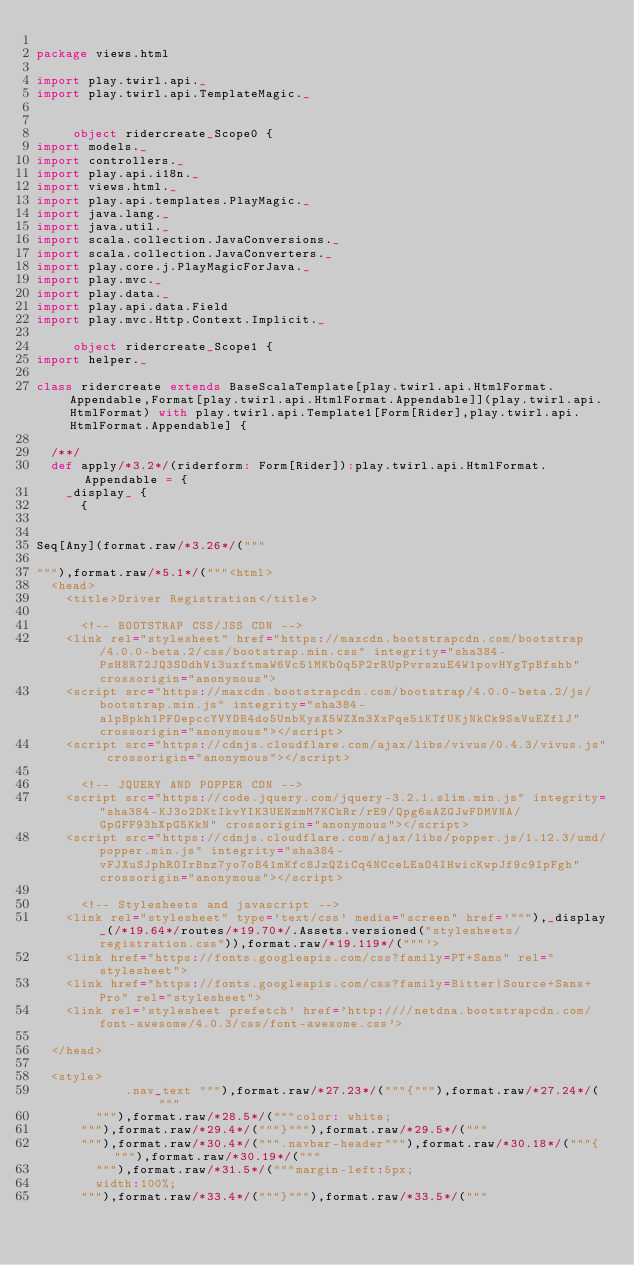Convert code to text. <code><loc_0><loc_0><loc_500><loc_500><_Scala_>
package views.html

import play.twirl.api._
import play.twirl.api.TemplateMagic._


     object ridercreate_Scope0 {
import models._
import controllers._
import play.api.i18n._
import views.html._
import play.api.templates.PlayMagic._
import java.lang._
import java.util._
import scala.collection.JavaConversions._
import scala.collection.JavaConverters._
import play.core.j.PlayMagicForJava._
import play.mvc._
import play.data._
import play.api.data.Field
import play.mvc.Http.Context.Implicit._

     object ridercreate_Scope1 {
import helper._

class ridercreate extends BaseScalaTemplate[play.twirl.api.HtmlFormat.Appendable,Format[play.twirl.api.HtmlFormat.Appendable]](play.twirl.api.HtmlFormat) with play.twirl.api.Template1[Form[Rider],play.twirl.api.HtmlFormat.Appendable] {

  /**/
  def apply/*3.2*/(riderform: Form[Rider]):play.twirl.api.HtmlFormat.Appendable = {
    _display_ {
      {


Seq[Any](format.raw/*3.26*/("""

"""),format.raw/*5.1*/("""<html>
	<head>
		<title>Driver Registration</title>

			<!-- BOOTSTRAP CSS/JSS CDN -->
		<link rel="stylesheet" href="https://maxcdn.bootstrapcdn.com/bootstrap/4.0.0-beta.2/css/bootstrap.min.css" integrity="sha384-PsH8R72JQ3SOdhVi3uxftmaW6Vc51MKb0q5P2rRUpPvrszuE4W1povHYgTpBfshb" crossorigin="anonymous">
		<script src="https://maxcdn.bootstrapcdn.com/bootstrap/4.0.0-beta.2/js/bootstrap.min.js" integrity="sha384-alpBpkh1PFOepccYVYDB4do5UnbKysX5WZXm3XxPqe5iKTfUKjNkCk9SaVuEZflJ" crossorigin="anonymous"></script>
		<script src="https://cdnjs.cloudflare.com/ajax/libs/vivus/0.4.3/vivus.js" crossorigin="anonymous"></script>

			<!-- JQUERY AND POPPER CDN -->
		<script src="https://code.jquery.com/jquery-3.2.1.slim.min.js" integrity="sha384-KJ3o2DKtIkvYIK3UENzmM7KCkRr/rE9/Qpg6aAZGJwFDMVNA/GpGFF93hXpG5KkN" crossorigin="anonymous"></script>
		<script src="https://cdnjs.cloudflare.com/ajax/libs/popper.js/1.12.3/umd/popper.min.js" integrity="sha384-vFJXuSJphROIrBnz7yo7oB41mKfc8JzQZiCq4NCceLEaO4IHwicKwpJf9c9IpFgh" crossorigin="anonymous"></script>

			<!-- Stylesheets and javascript -->
		<link rel="stylesheet" type='text/css' media="screen" href='"""),_display_(/*19.64*/routes/*19.70*/.Assets.versioned("stylesheets/registration.css")),format.raw/*19.119*/("""'>
		<link href="https://fonts.googleapis.com/css?family=PT+Sans" rel="stylesheet">
		<link href="https://fonts.googleapis.com/css?family=Bitter|Source+Sans+Pro" rel="stylesheet">
		<link rel='stylesheet prefetch' href='http:////netdna.bootstrapcdn.com/font-awesome/4.0.3/css/font-awesome.css'>

	</head>

	<style>
            .nav_text """),format.raw/*27.23*/("""{"""),format.raw/*27.24*/("""
				"""),format.raw/*28.5*/("""color: white;
			"""),format.raw/*29.4*/("""}"""),format.raw/*29.5*/("""
			"""),format.raw/*30.4*/(""".navbar-header"""),format.raw/*30.18*/("""{"""),format.raw/*30.19*/("""
				"""),format.raw/*31.5*/("""margin-left:5px;
				width:100%;
			"""),format.raw/*33.4*/("""}"""),format.raw/*33.5*/("""</code> 